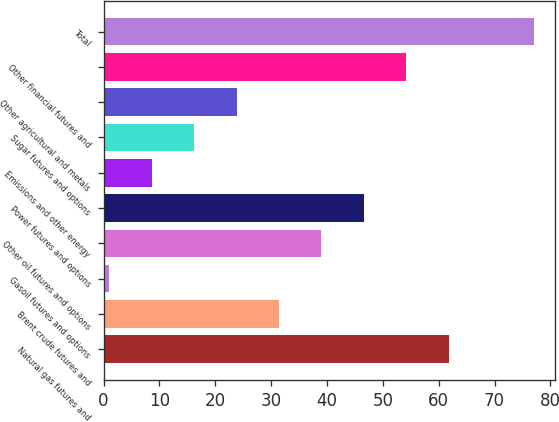<chart> <loc_0><loc_0><loc_500><loc_500><bar_chart><fcel>Natural gas futures and<fcel>Brent crude futures and<fcel>Gasoil futures and options<fcel>Other oil futures and options<fcel>Power futures and options<fcel>Emissions and other energy<fcel>Sugar futures and options<fcel>Other agricultural and metals<fcel>Other financial futures and<fcel>Total<nl><fcel>61.8<fcel>31.4<fcel>1<fcel>39<fcel>46.6<fcel>8.6<fcel>16.2<fcel>23.8<fcel>54.2<fcel>77<nl></chart> 